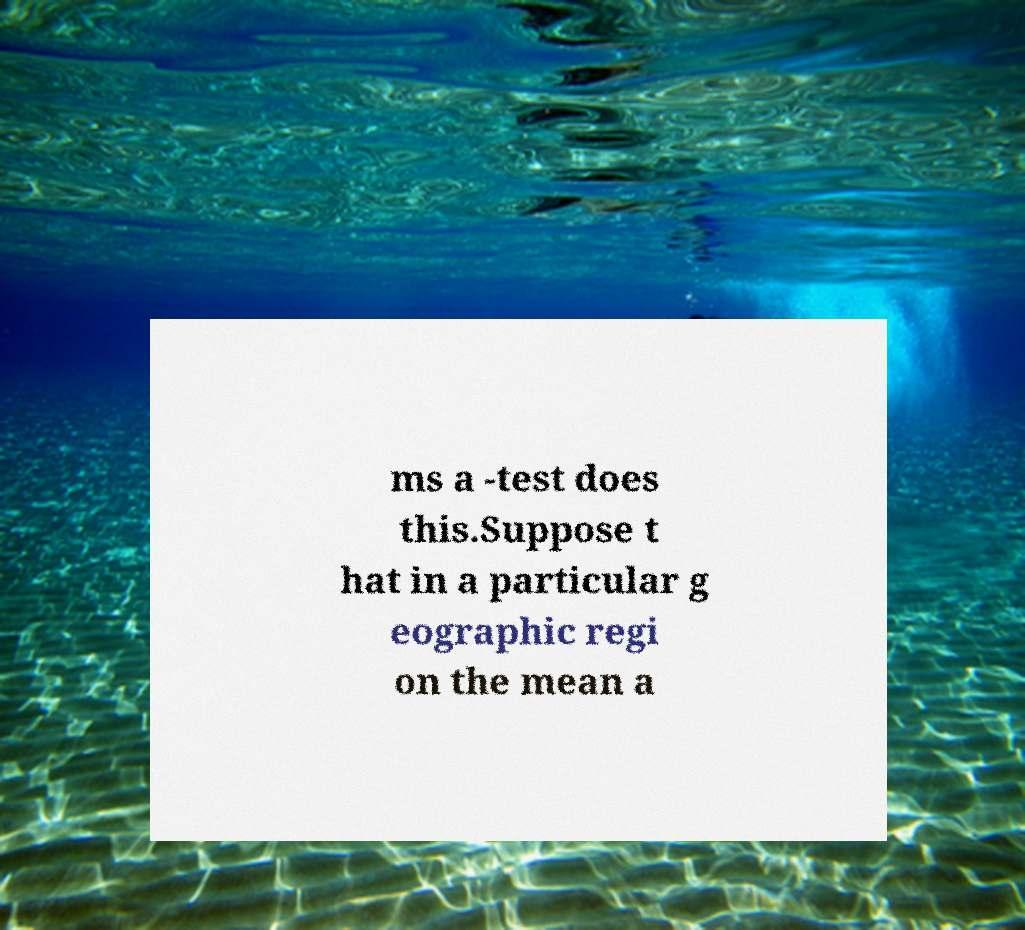Please identify and transcribe the text found in this image. ms a -test does this.Suppose t hat in a particular g eographic regi on the mean a 